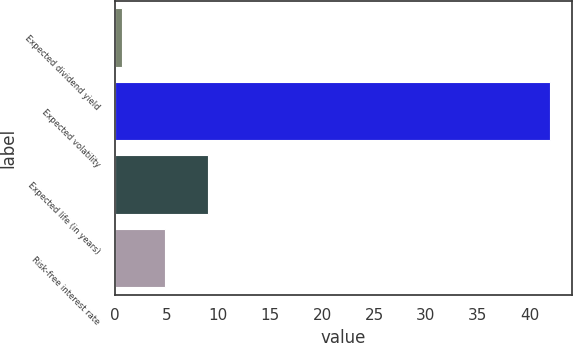Convert chart to OTSL. <chart><loc_0><loc_0><loc_500><loc_500><bar_chart><fcel>Expected dividend yield<fcel>Expected volatility<fcel>Expected life (in years)<fcel>Risk-free interest rate<nl><fcel>0.74<fcel>41.96<fcel>8.98<fcel>4.86<nl></chart> 